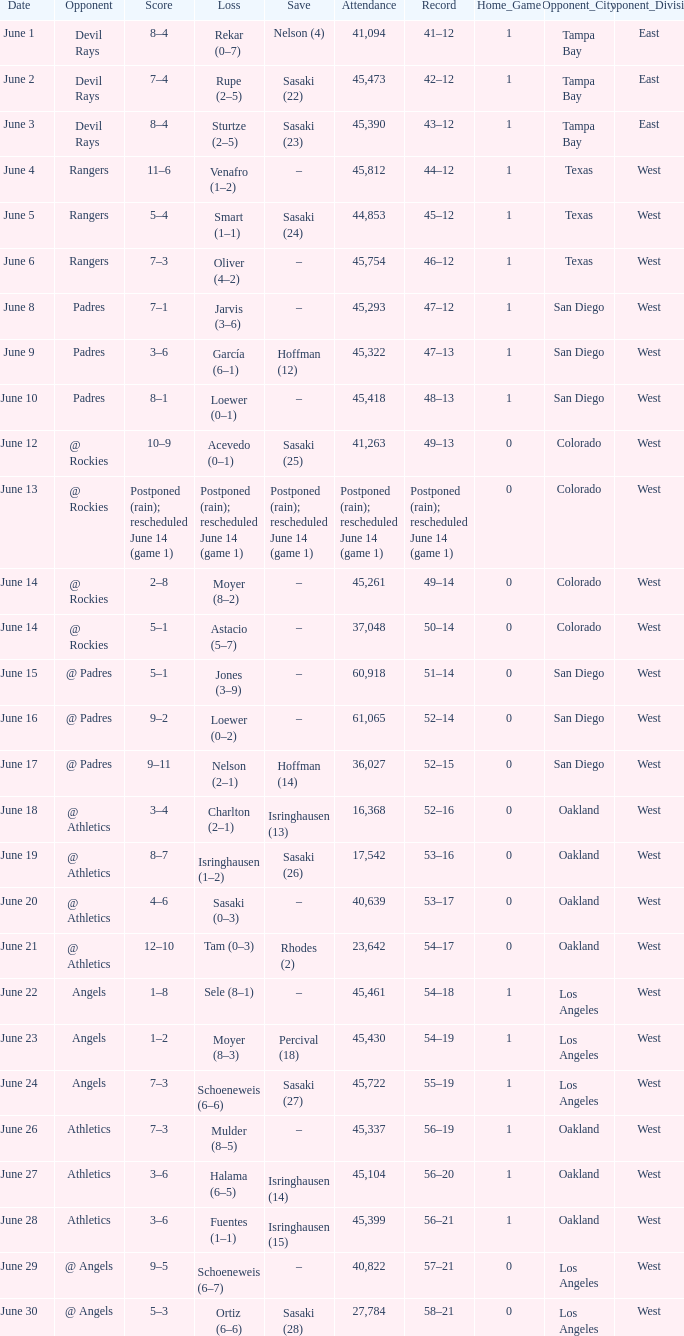What was the attendance of the Mariners game when they had a record of 56–20? 45104.0. 